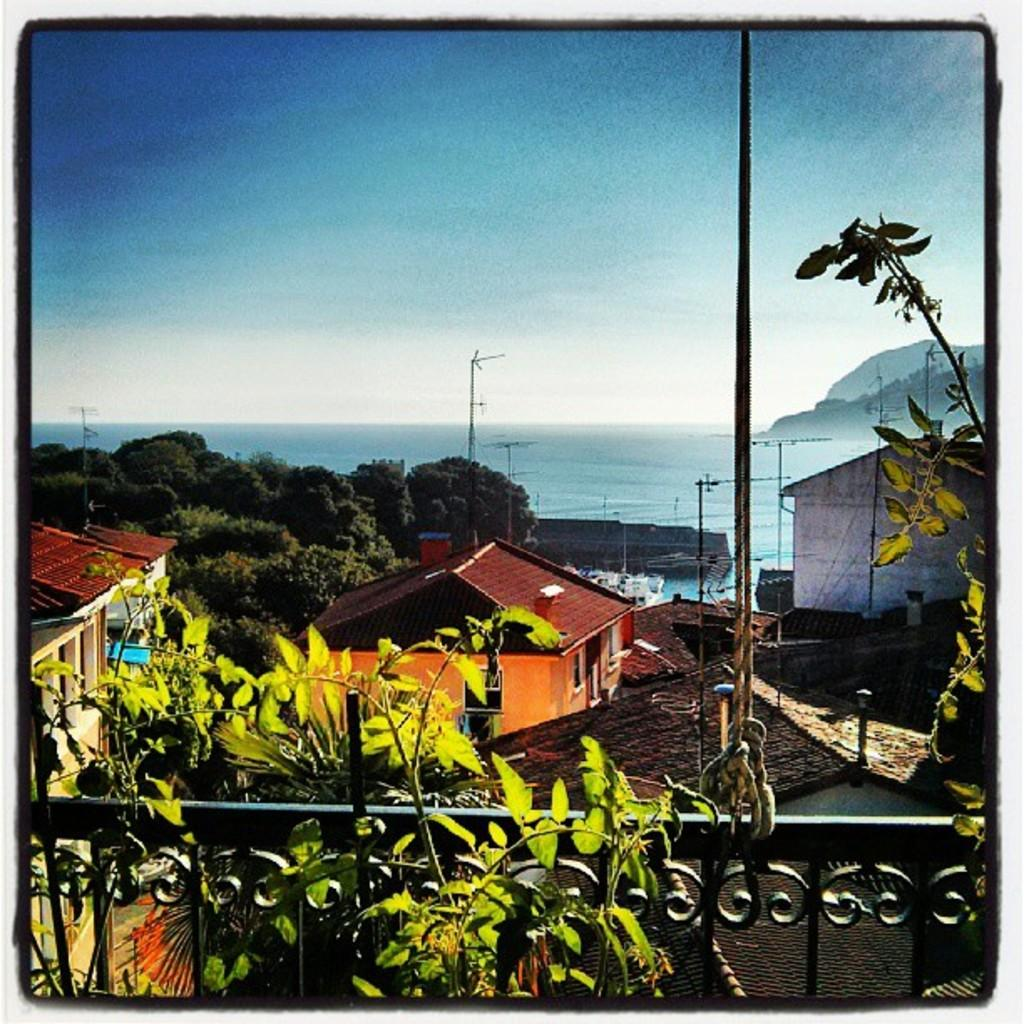What type of barrier can be seen in the image? There is a fence in the image. What type of vegetation is present in the image? There are plants and trees in the image. What is attached to the fence in the image? A rope is tied to the fence. What type of structures can be seen in the image? There are houses with roofs in the image. What other natural elements are present in the image? There are poles in the image. What can be seen in the background of the image? There is a beach and mountains visible in the background. What is the condition of the sky in the image? The sky is visible and appears cloudy. What type of property is being sold in the image? There is no indication of a property being sold in the image. What type of lake can be seen in the image? There is no lake present in the image. 